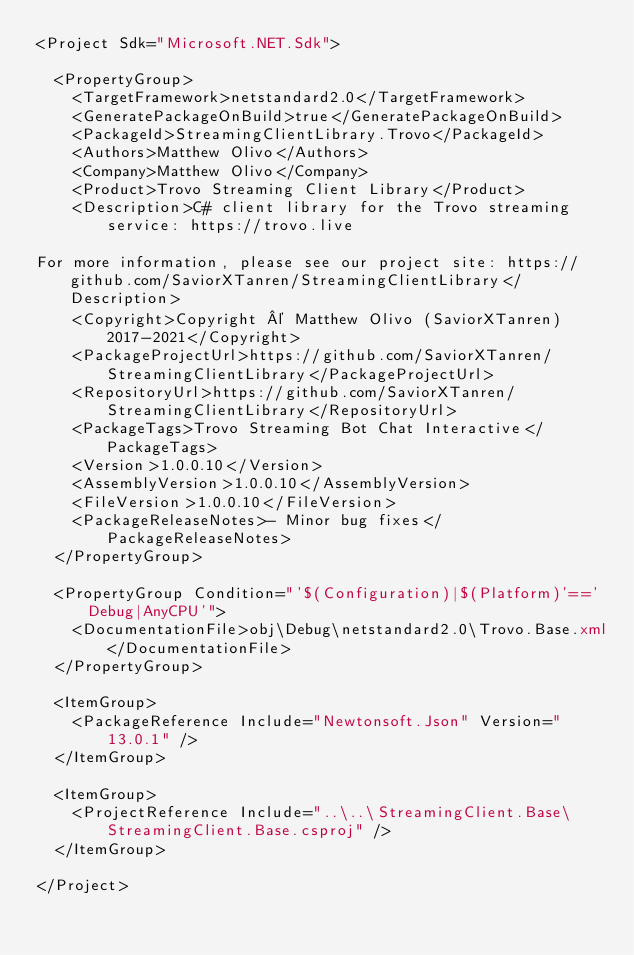<code> <loc_0><loc_0><loc_500><loc_500><_XML_><Project Sdk="Microsoft.NET.Sdk">

  <PropertyGroup>
    <TargetFramework>netstandard2.0</TargetFramework>
    <GeneratePackageOnBuild>true</GeneratePackageOnBuild>
    <PackageId>StreamingClientLibrary.Trovo</PackageId>
    <Authors>Matthew Olivo</Authors>
    <Company>Matthew Olivo</Company>
    <Product>Trovo Streaming Client Library</Product>
    <Description>C# client library for the Trovo streaming service: https://trovo.live
      
For more information, please see our project site: https://github.com/SaviorXTanren/StreamingClientLibrary</Description>
    <Copyright>Copyright © Matthew Olivo (SaviorXTanren) 2017-2021</Copyright>
    <PackageProjectUrl>https://github.com/SaviorXTanren/StreamingClientLibrary</PackageProjectUrl>
    <RepositoryUrl>https://github.com/SaviorXTanren/StreamingClientLibrary</RepositoryUrl>
    <PackageTags>Trovo Streaming Bot Chat Interactive</PackageTags>
    <Version>1.0.0.10</Version>
    <AssemblyVersion>1.0.0.10</AssemblyVersion>
    <FileVersion>1.0.0.10</FileVersion>
    <PackageReleaseNotes>- Minor bug fixes</PackageReleaseNotes>
  </PropertyGroup>

  <PropertyGroup Condition="'$(Configuration)|$(Platform)'=='Debug|AnyCPU'">
    <DocumentationFile>obj\Debug\netstandard2.0\Trovo.Base.xml</DocumentationFile>
  </PropertyGroup>

  <ItemGroup>
    <PackageReference Include="Newtonsoft.Json" Version="13.0.1" />
  </ItemGroup>

  <ItemGroup>
    <ProjectReference Include="..\..\StreamingClient.Base\StreamingClient.Base.csproj" />
  </ItemGroup>

</Project>
</code> 